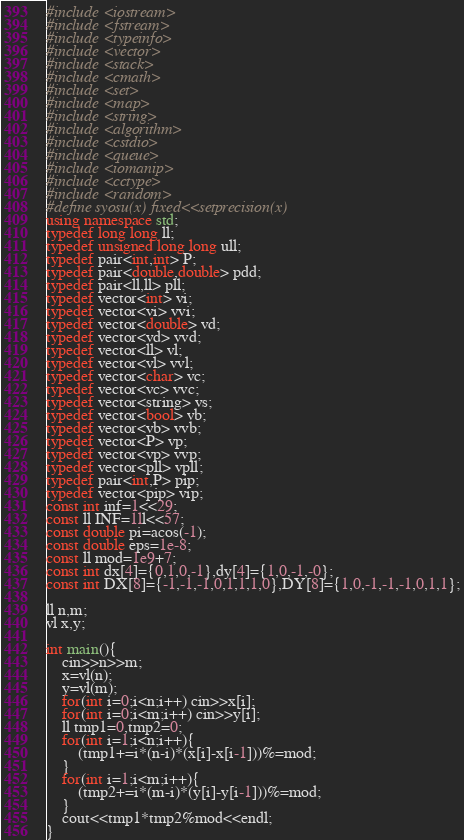<code> <loc_0><loc_0><loc_500><loc_500><_C++_>#include <iostream>
#include <fstream>
#include <typeinfo>
#include <vector>
#include <stack>
#include <cmath>
#include <set>
#include <map>
#include <string>
#include <algorithm>
#include <cstdio>
#include <queue>
#include <iomanip>
#include <cctype>
#include <random>
#define syosu(x) fixed<<setprecision(x)
using namespace std;
typedef long long ll;
typedef unsigned long long ull;
typedef pair<int,int> P;
typedef pair<double,double> pdd;
typedef pair<ll,ll> pll;
typedef vector<int> vi;
typedef vector<vi> vvi;
typedef vector<double> vd;
typedef vector<vd> vvd;
typedef vector<ll> vl;
typedef vector<vl> vvl;
typedef vector<char> vc;
typedef vector<vc> vvc;
typedef vector<string> vs;
typedef vector<bool> vb;
typedef vector<vb> vvb;
typedef vector<P> vp;
typedef vector<vp> vvp;
typedef vector<pll> vpll;
typedef pair<int,P> pip;
typedef vector<pip> vip;
const int inf=1<<29;
const ll INF=1ll<<57;
const double pi=acos(-1);
const double eps=1e-8;
const ll mod=1e9+7;
const int dx[4]={0,1,0,-1},dy[4]={1,0,-1,-0};
const int DX[8]={-1,-1,-1,0,1,1,1,0},DY[8]={1,0,-1,-1,-1,0,1,1};

ll n,m;
vl x,y;

int main(){
	cin>>n>>m;
	x=vl(n);
	y=vl(m);
	for(int i=0;i<n;i++) cin>>x[i];
	for(int i=0;i<m;i++) cin>>y[i];
	ll tmp1=0,tmp2=0;
	for(int i=1;i<n;i++){
		(tmp1+=i*(n-i)*(x[i]-x[i-1]))%=mod;
	}
	for(int i=1;i<m;i++){
		(tmp2+=i*(m-i)*(y[i]-y[i-1]))%=mod;
	}
	cout<<tmp1*tmp2%mod<<endl;
}</code> 